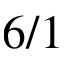<formula> <loc_0><loc_0><loc_500><loc_500>6 / 1</formula> 